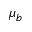<formula> <loc_0><loc_0><loc_500><loc_500>\mu _ { b }</formula> 